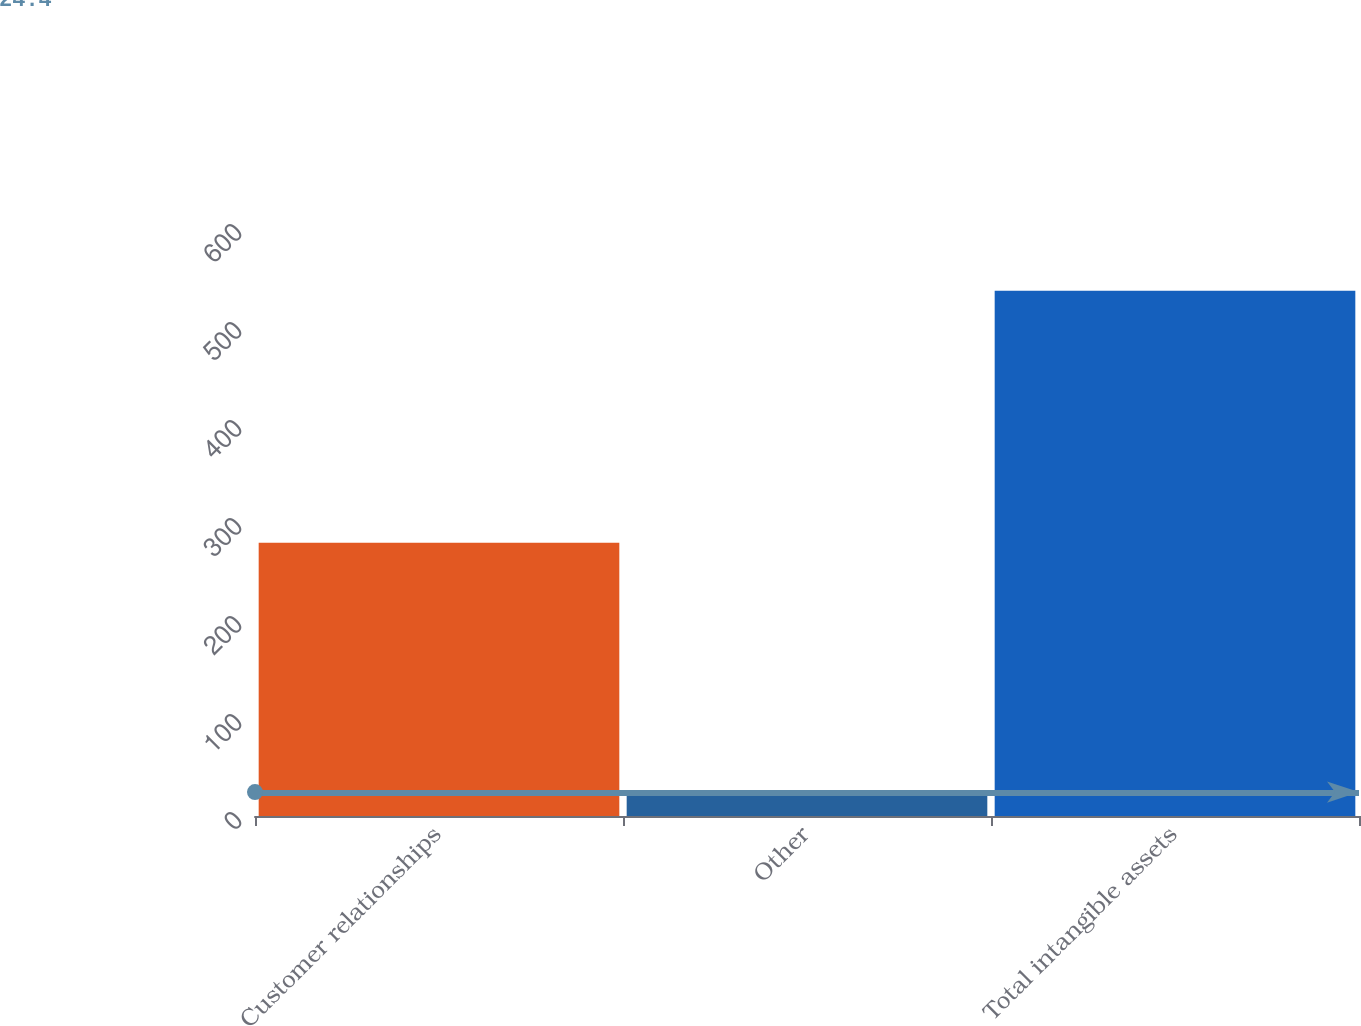Convert chart to OTSL. <chart><loc_0><loc_0><loc_500><loc_500><bar_chart><fcel>Customer relationships<fcel>Other<fcel>Total intangible assets<nl><fcel>278.9<fcel>24.4<fcel>536<nl></chart> 